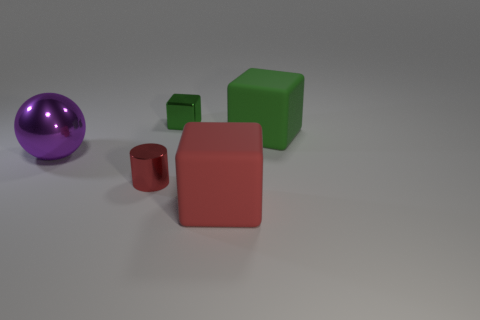Add 2 brown balls. How many objects exist? 7 Subtract all spheres. How many objects are left? 4 Add 4 big red cubes. How many big red cubes are left? 5 Add 3 small cylinders. How many small cylinders exist? 4 Subtract 0 cyan cylinders. How many objects are left? 5 Subtract all large purple spheres. Subtract all purple balls. How many objects are left? 3 